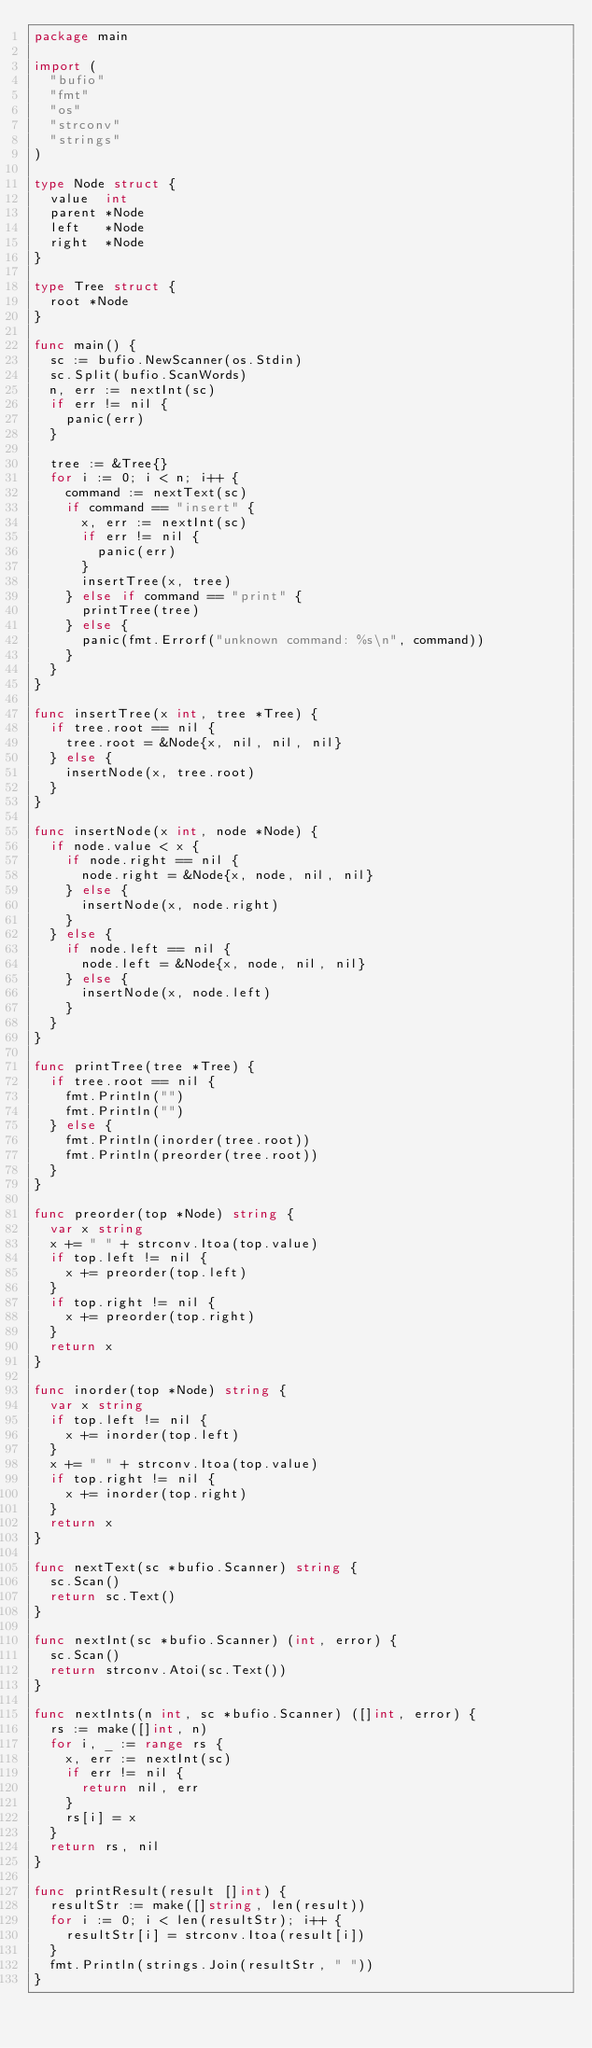Convert code to text. <code><loc_0><loc_0><loc_500><loc_500><_Go_>package main

import (
	"bufio"
	"fmt"
	"os"
	"strconv"
	"strings"
)

type Node struct {
	value  int
	parent *Node
	left   *Node
	right  *Node
}

type Tree struct {
	root *Node
}

func main() {
	sc := bufio.NewScanner(os.Stdin)
	sc.Split(bufio.ScanWords)
	n, err := nextInt(sc)
	if err != nil {
		panic(err)
	}

	tree := &Tree{}
	for i := 0; i < n; i++ {
		command := nextText(sc)
		if command == "insert" {
			x, err := nextInt(sc)
			if err != nil {
				panic(err)
			}
			insertTree(x, tree)
		} else if command == "print" {
			printTree(tree)
		} else {
			panic(fmt.Errorf("unknown command: %s\n", command))
		}
	}
}

func insertTree(x int, tree *Tree) {
	if tree.root == nil {
		tree.root = &Node{x, nil, nil, nil}
	} else {
		insertNode(x, tree.root)
	}
}

func insertNode(x int, node *Node) {
	if node.value < x {
		if node.right == nil {
			node.right = &Node{x, node, nil, nil}
		} else {
			insertNode(x, node.right)
		}
	} else {
		if node.left == nil {
			node.left = &Node{x, node, nil, nil}
		} else {
			insertNode(x, node.left)
		}
	}
}

func printTree(tree *Tree) {
	if tree.root == nil {
		fmt.Println("")
		fmt.Println("")
	} else {
		fmt.Println(inorder(tree.root))
		fmt.Println(preorder(tree.root))
	}
}

func preorder(top *Node) string {
	var x string
	x += " " + strconv.Itoa(top.value)
	if top.left != nil {
		x += preorder(top.left)
	}
	if top.right != nil {
		x += preorder(top.right)
	}
	return x
}

func inorder(top *Node) string {
	var x string
	if top.left != nil {
		x += inorder(top.left)
	}
	x += " " + strconv.Itoa(top.value)
	if top.right != nil {
		x += inorder(top.right)
	}
	return x
}

func nextText(sc *bufio.Scanner) string {
	sc.Scan()
	return sc.Text()
}

func nextInt(sc *bufio.Scanner) (int, error) {
	sc.Scan()
	return strconv.Atoi(sc.Text())
}

func nextInts(n int, sc *bufio.Scanner) ([]int, error) {
	rs := make([]int, n)
	for i, _ := range rs {
		x, err := nextInt(sc)
		if err != nil {
			return nil, err
		}
		rs[i] = x
	}
	return rs, nil
}

func printResult(result []int) {
	resultStr := make([]string, len(result))
	for i := 0; i < len(resultStr); i++ {
		resultStr[i] = strconv.Itoa(result[i])
	}
	fmt.Println(strings.Join(resultStr, " "))
}

</code> 